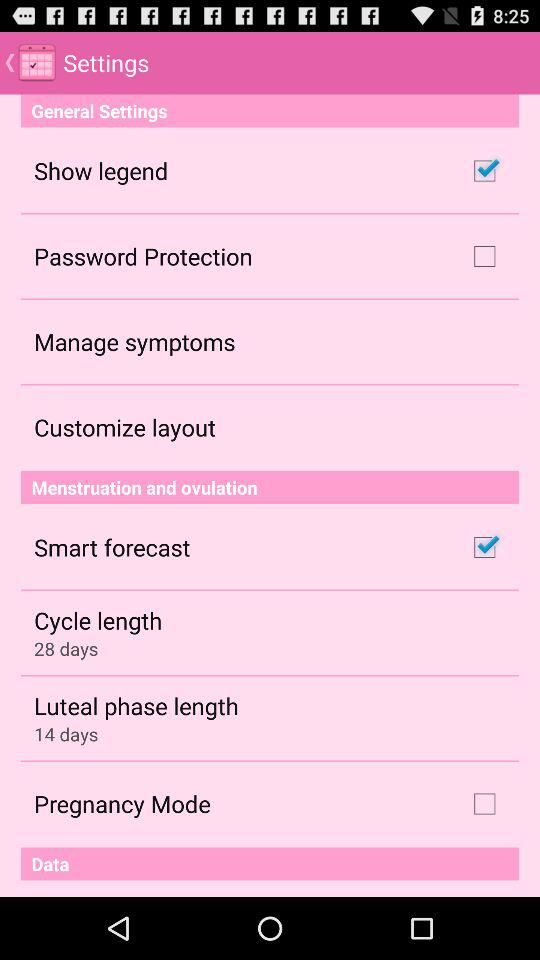What is the status of "Smart forecast"? The status of "Smart forecast" is "on". 